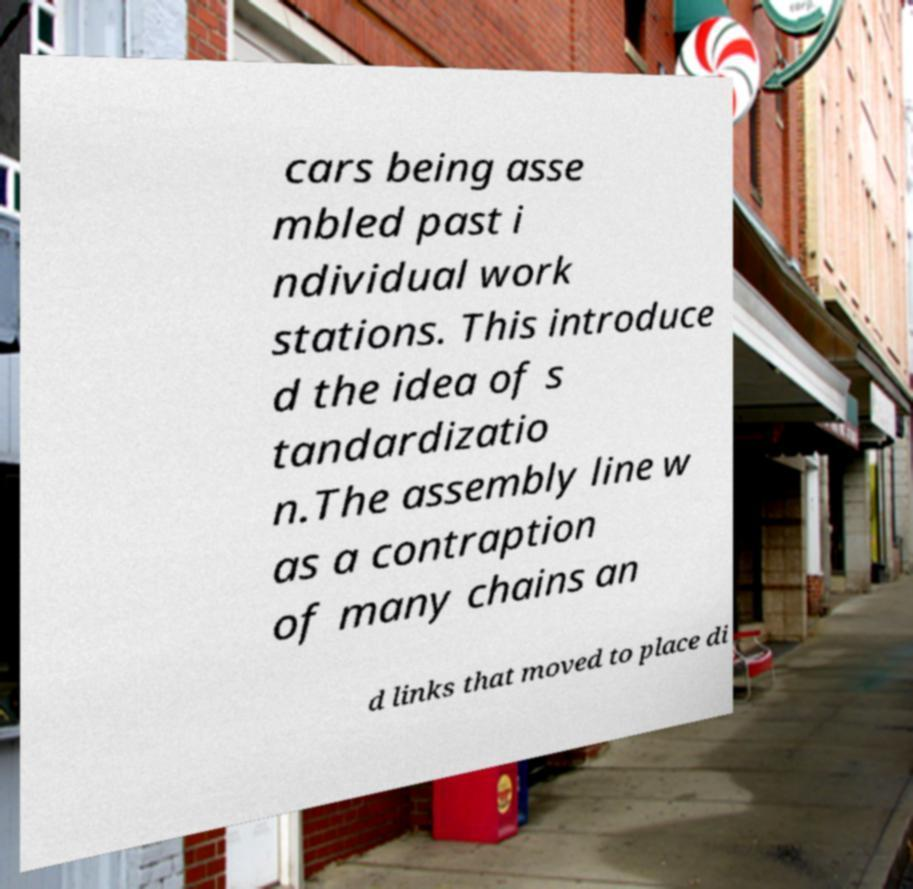Could you assist in decoding the text presented in this image and type it out clearly? cars being asse mbled past i ndividual work stations. This introduce d the idea of s tandardizatio n.The assembly line w as a contraption of many chains an d links that moved to place di 